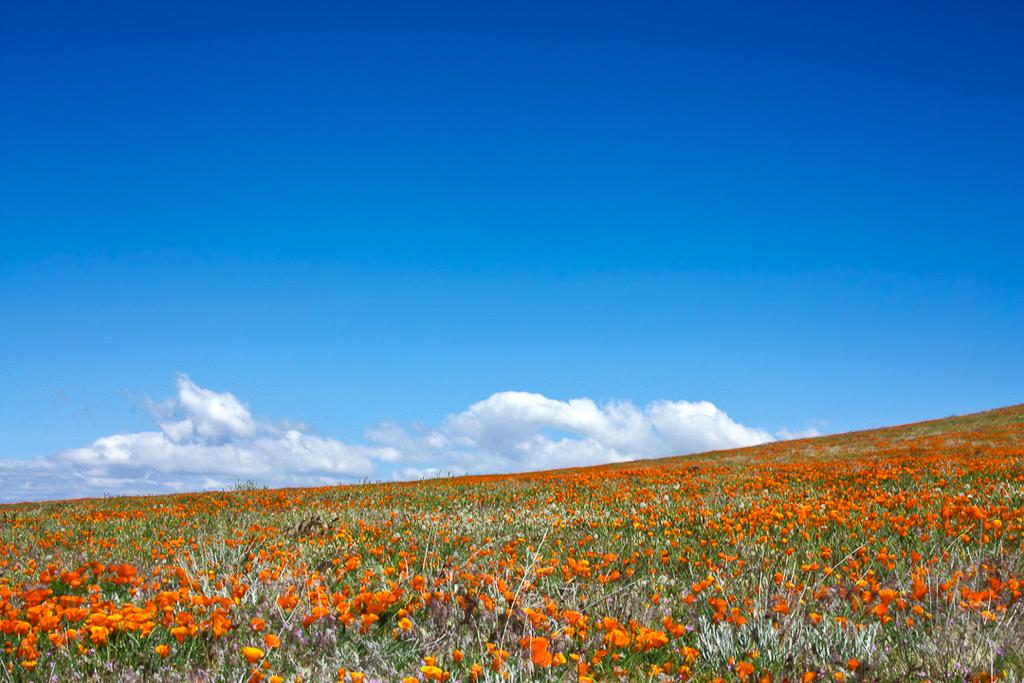What is the main subject of the image? The main subject of the image is a big flower plant garden. What can be seen in the sky in the image? Clouds are visible in the sky. What type of square structure can be seen in the garden? There is no square structure present in the garden; the image only features a big flower plant garden and clouds in the sky. 